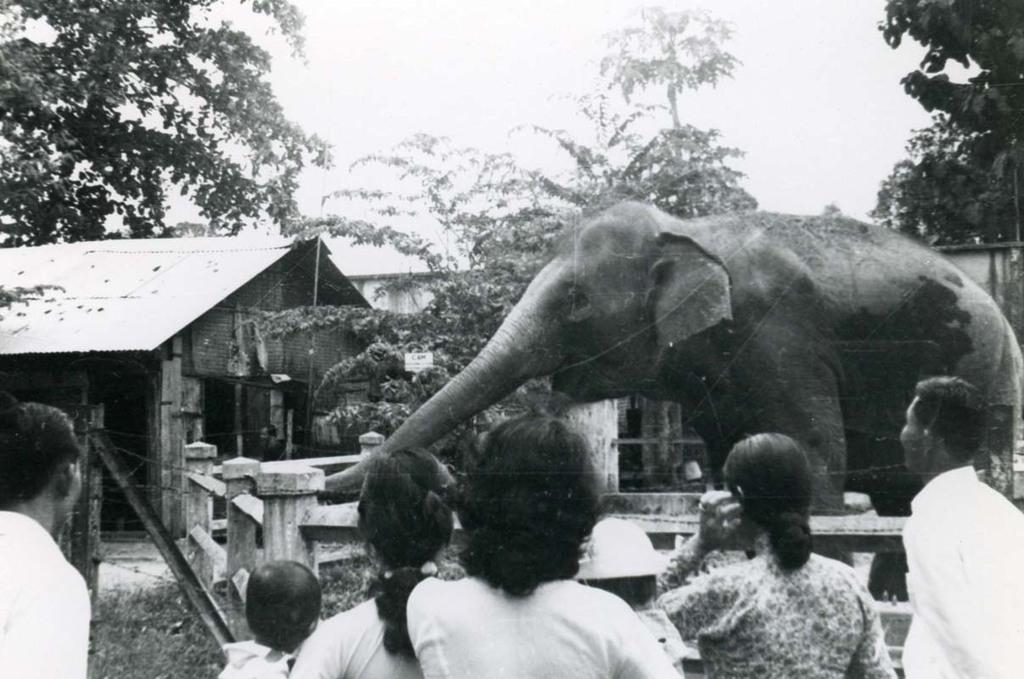How many persons are in the image? There are persons in the image, but the exact number is not specified. What are the persons looking at in the image? The persons are looking at an elephant in the image. Where is the elephant located in relation to the persons? The elephant is in front of the persons in the image. What can be seen in the background of the image? There are trees and houses in the background of the image. What type of crime is being committed by the rat in the image? There is no rat present in the image, and therefore no crime can be committed by a rat. 